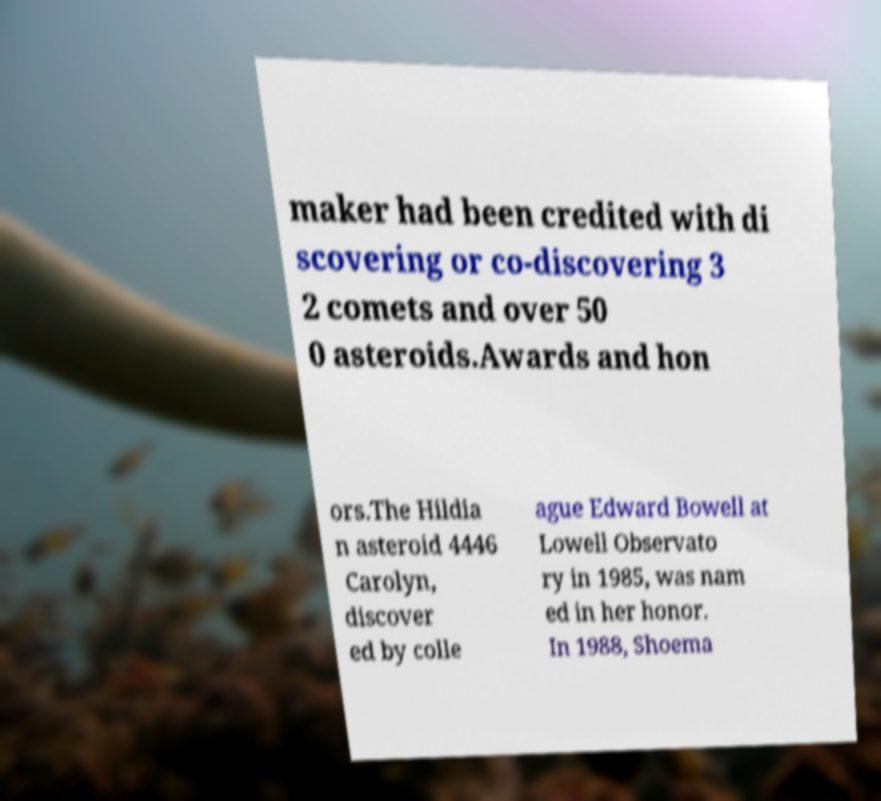I need the written content from this picture converted into text. Can you do that? maker had been credited with di scovering or co-discovering 3 2 comets and over 50 0 asteroids.Awards and hon ors.The Hildia n asteroid 4446 Carolyn, discover ed by colle ague Edward Bowell at Lowell Observato ry in 1985, was nam ed in her honor. In 1988, Shoema 